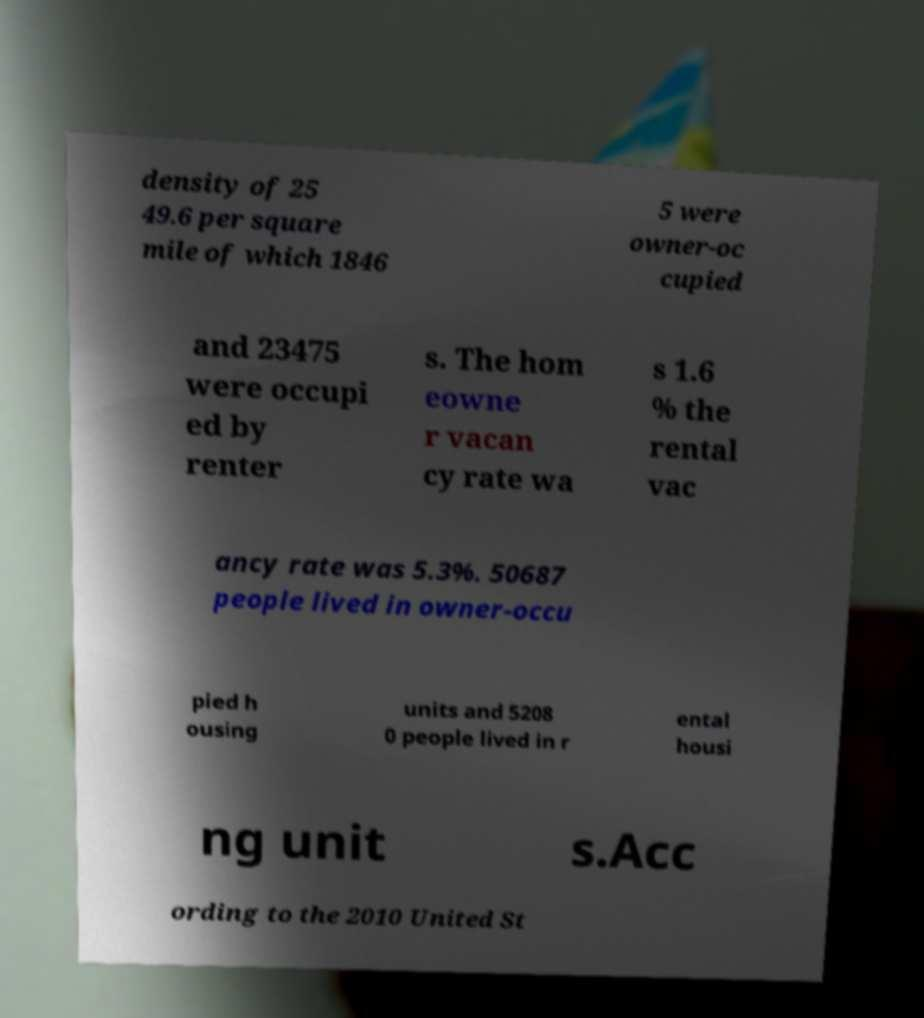Could you extract and type out the text from this image? density of 25 49.6 per square mile of which 1846 5 were owner-oc cupied and 23475 were occupi ed by renter s. The hom eowne r vacan cy rate wa s 1.6 % the rental vac ancy rate was 5.3%. 50687 people lived in owner-occu pied h ousing units and 5208 0 people lived in r ental housi ng unit s.Acc ording to the 2010 United St 